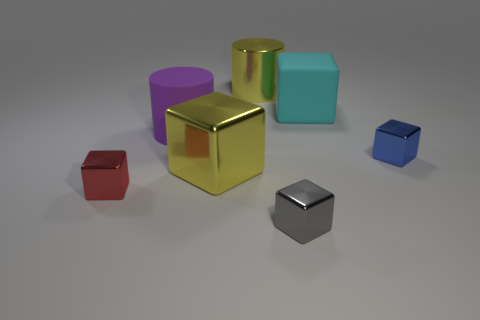Does the blue metallic object have the same size as the gray object that is to the left of the large cyan matte block?
Provide a succinct answer. Yes. What is the material of the small red thing that is the same shape as the large cyan matte thing?
Keep it short and to the point. Metal. What number of other objects are the same size as the gray block?
Give a very brief answer. 2. What shape is the matte thing to the right of the big yellow thing that is behind the large cube that is in front of the blue thing?
Provide a succinct answer. Cube. There is a small object that is behind the gray metal block and on the left side of the big cyan matte cube; what is its shape?
Provide a succinct answer. Cube. What number of things are cyan things or large things behind the cyan block?
Offer a terse response. 2. Do the yellow cylinder and the cyan cube have the same material?
Your answer should be compact. No. How many other objects are there of the same shape as the tiny gray shiny thing?
Provide a short and direct response. 4. What is the size of the cube that is both behind the small red thing and left of the small gray thing?
Keep it short and to the point. Large. What number of matte objects are big cylinders or big blue objects?
Offer a very short reply. 1. 